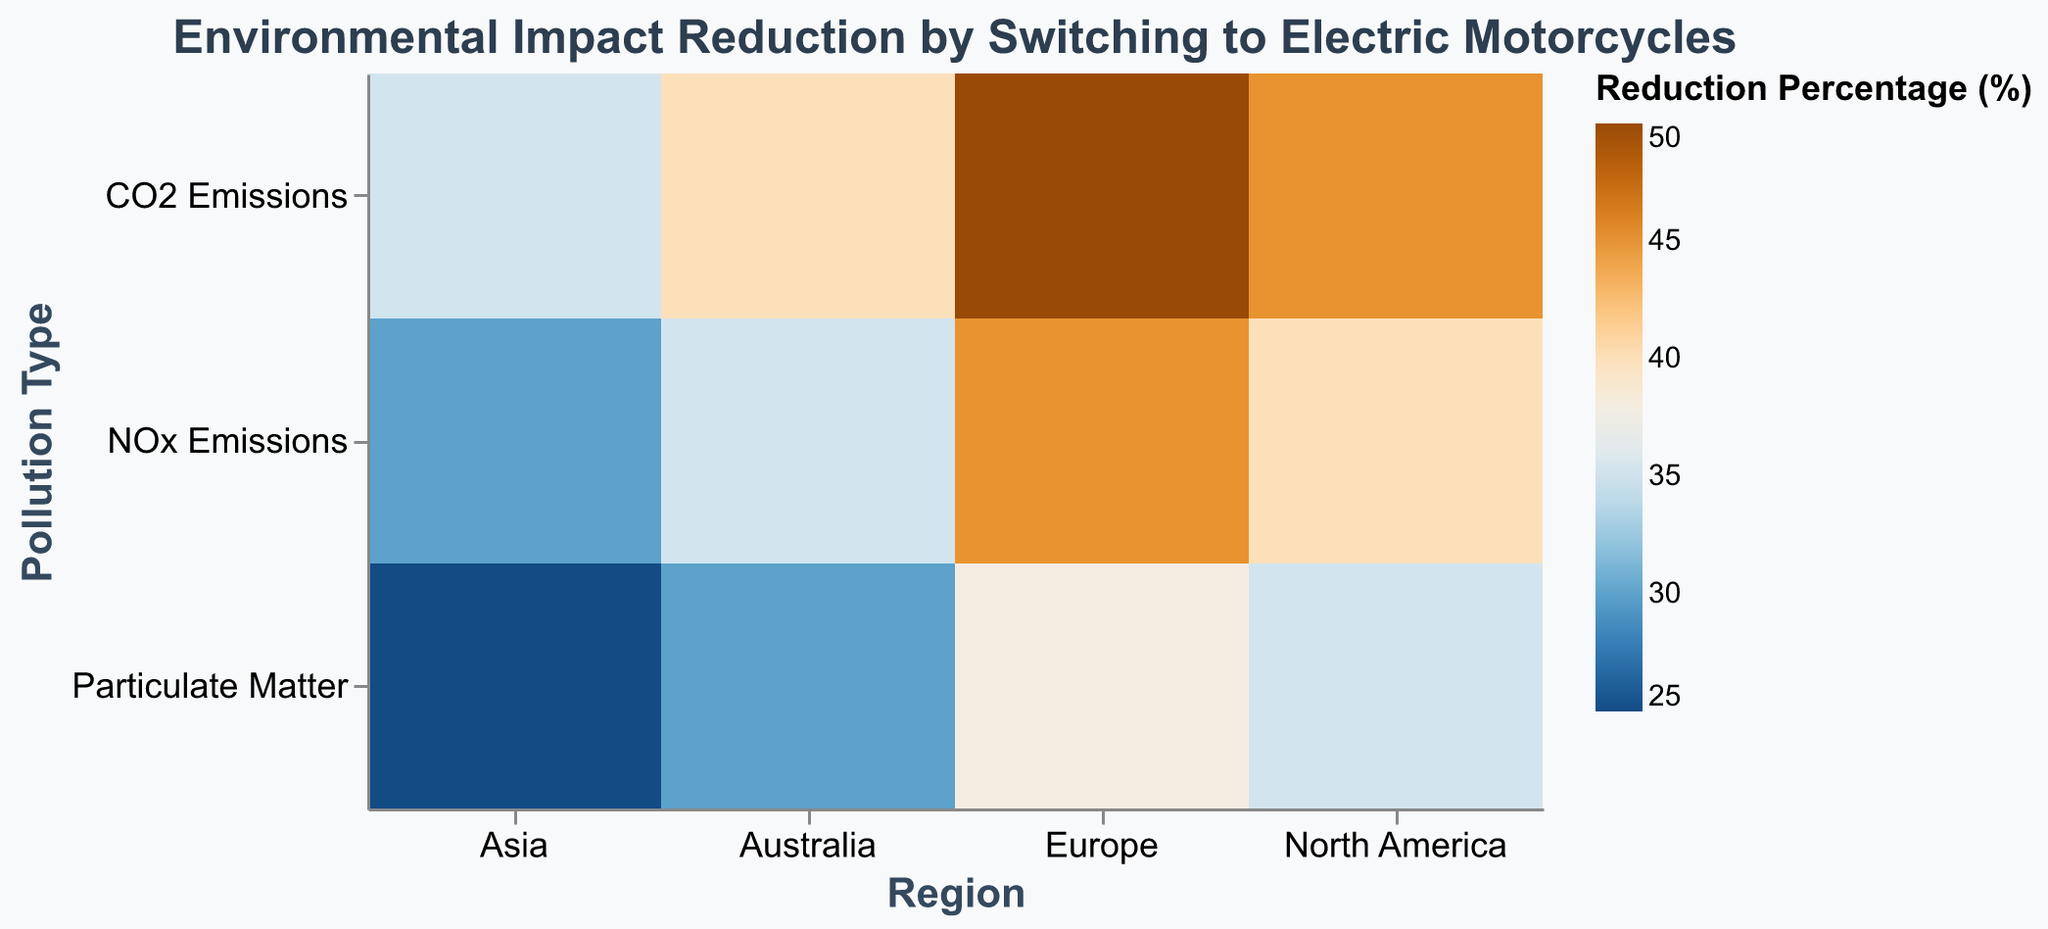What is the title of the heatmap? The title can be found at the top of the heatmap. It states, "Environmental Impact Reduction by Switching to Electric Motorcycles"
Answer: Environmental Impact Reduction by Switching to Electric Motorcycles Which region shows the highest reduction percentage for CO2 emissions? The color gradient for the reduction percentage indicates that the highest reduction percentage for CO2 Emissions is in Europe with a percentage of 50%.
Answer: Europe What is the reduction percentage for particulate matter in North America? The color and tooltip on the cell that intersects at "North America" on the x-axis and "Particulate Matter" on the y-axis show a reduction percentage of 35%.
Answer: 35% Which pollution type has the lowest reduction percentage in Asia? Compare the values for all pollution types within the Asia region by examining the color intensity and tooltips. "Particulate Matter" has the lowest reduction percentage of 25%.
Answer: Particulate Matter How does the reduction percentage for NOx emissions differ between North America and Australia? Look at the cells for NOx emissions in both regions. North America shows a reduction of 40%, while Australia shows a reduction of 35%, giving a difference of 5%.
Answer: 5% What is the median reduction percentage for all pollution types in Europe? List the reduction percentages for Europe (50%, 45%, 38%) and calculate the median, which is the middle value when they're in order: 38%, 45%, 50%. So, the median is 45%.
Answer: 45% Which region has the most uniform reduction percentages across all pollution types? Check for the region where the reductions are closest in value. Australia has values of 40%, 35%, and 30%, which differ by 5% and 10%, indicating the most uniform reduction.
Answer: Australia Which pollution type shows the highest average reduction percentage across all regions? Calculate the average for each pollution type. CO2 Emissions: (45+50+35+40)/4=42.5, NOx Emissions: (40+45+30+35)/4=37.5, Particulate Matter: (35+38+25+30)/4=32. CO2 Emissions has the highest average reduction at 42.5%.
Answer: CO2 Emissions By how much does the reduction percentage for CO2 Emissions in Europe exceed that in Asia? Look at the reduction percentages for CO2 Emissions in Europe and Asia, which are 50% and 35% respectively. The difference is 50% - 35% = 15%.
Answer: 15% Is the reduction percentage for NOx Emissions higher in North America or Europe? Compare the reduction percentages for NOx Emissions in both regions. North America has 40% while Europe has 45%, so it's higher in Europe.
Answer: Europe 